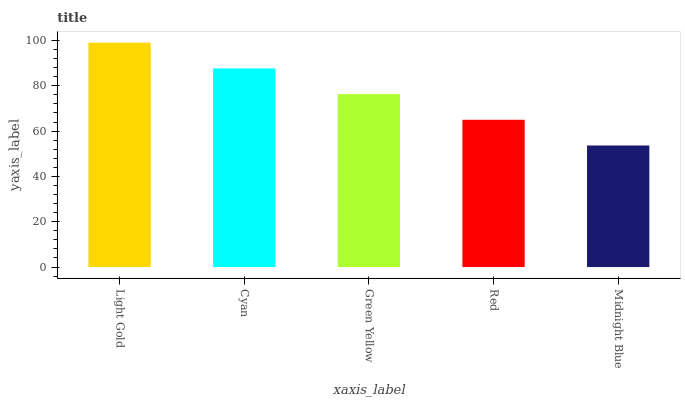Is Midnight Blue the minimum?
Answer yes or no. Yes. Is Light Gold the maximum?
Answer yes or no. Yes. Is Cyan the minimum?
Answer yes or no. No. Is Cyan the maximum?
Answer yes or no. No. Is Light Gold greater than Cyan?
Answer yes or no. Yes. Is Cyan less than Light Gold?
Answer yes or no. Yes. Is Cyan greater than Light Gold?
Answer yes or no. No. Is Light Gold less than Cyan?
Answer yes or no. No. Is Green Yellow the high median?
Answer yes or no. Yes. Is Green Yellow the low median?
Answer yes or no. Yes. Is Cyan the high median?
Answer yes or no. No. Is Light Gold the low median?
Answer yes or no. No. 